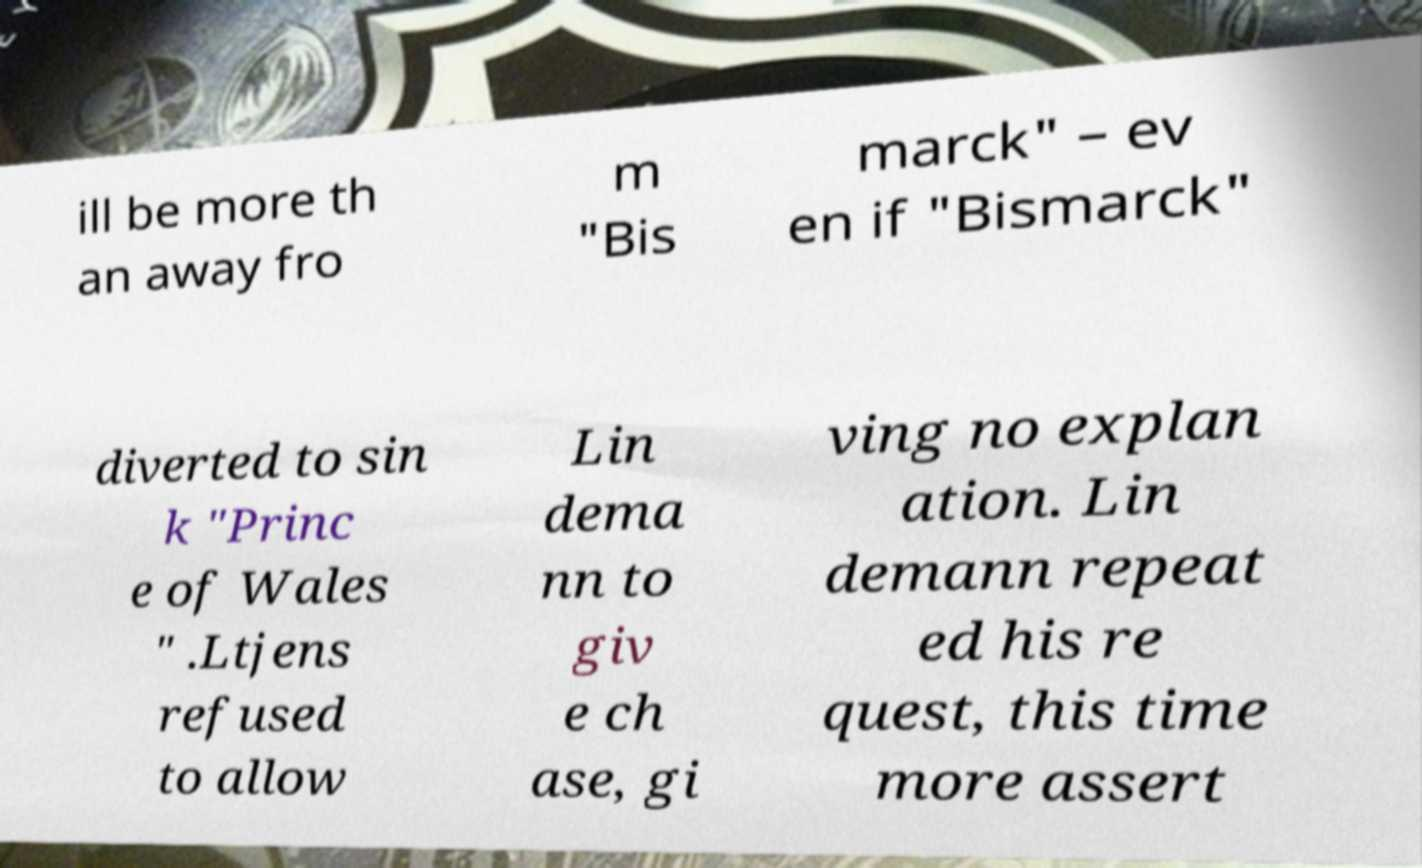There's text embedded in this image that I need extracted. Can you transcribe it verbatim? ill be more th an away fro m "Bis marck" – ev en if "Bismarck" diverted to sin k "Princ e of Wales " .Ltjens refused to allow Lin dema nn to giv e ch ase, gi ving no explan ation. Lin demann repeat ed his re quest, this time more assert 